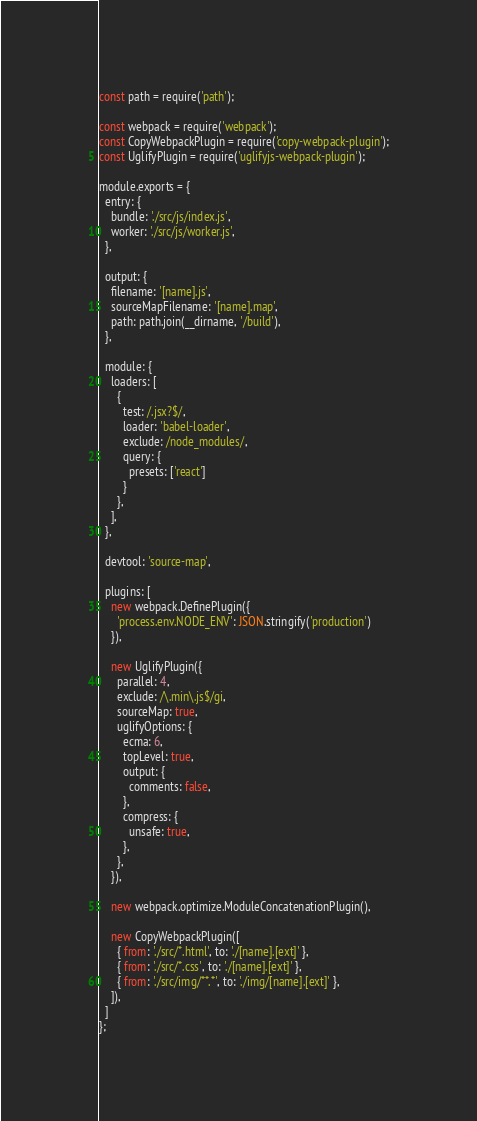<code> <loc_0><loc_0><loc_500><loc_500><_JavaScript_>const path = require('path');

const webpack = require('webpack');
const CopyWebpackPlugin = require('copy-webpack-plugin');
const UglifyPlugin = require('uglifyjs-webpack-plugin');

module.exports = {
  entry: {
    bundle: './src/js/index.js',
    worker: './src/js/worker.js',
  },

  output: {
    filename: '[name].js',
    sourceMapFilename: '[name].map',
    path: path.join(__dirname, '/build'),
  },

  module: {
    loaders: [
      {
        test: /.jsx?$/,
        loader: 'babel-loader',
        exclude: /node_modules/,
        query: {
          presets: ['react']
        }
      },
    ],
  },

  devtool: 'source-map',

  plugins: [
    new webpack.DefinePlugin({
      'process.env.NODE_ENV': JSON.stringify('production')
    }),

    new UglifyPlugin({
      parallel: 4,
      exclude: /\.min\.js$/gi,
      sourceMap: true,
      uglifyOptions: {
        ecma: 6,
        topLevel: true,
        output: {
          comments: false,
        },
        compress: {
          unsafe: true,
        },
      },
    }),

    new webpack.optimize.ModuleConcatenationPlugin(),

    new CopyWebpackPlugin([
      { from: './src/*.html', to: './[name].[ext]' },
      { from: './src/*.css', to: './[name].[ext]' },
      { from: './src/img/**.*', to: './img/[name].[ext]' },
    ]),
  ]
};
</code> 